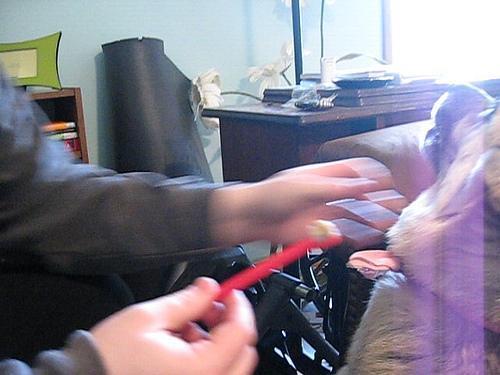How many people are in the room?
Give a very brief answer. 1. 